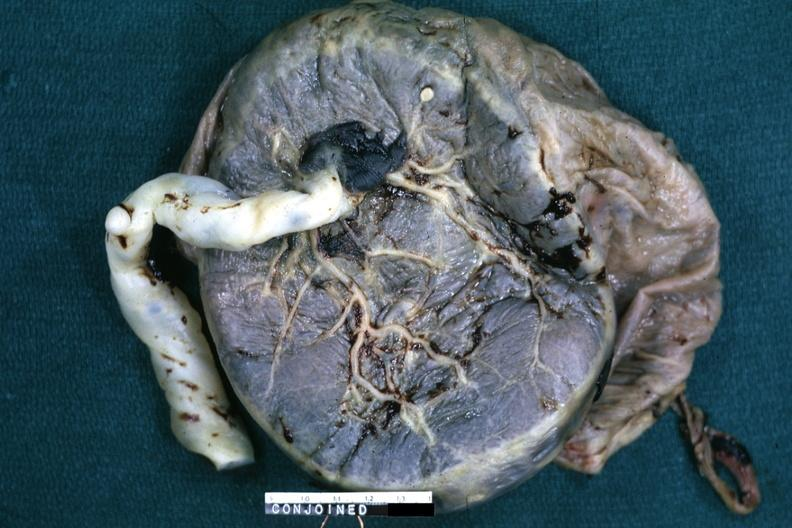s history present?
Answer the question using a single word or phrase. No 